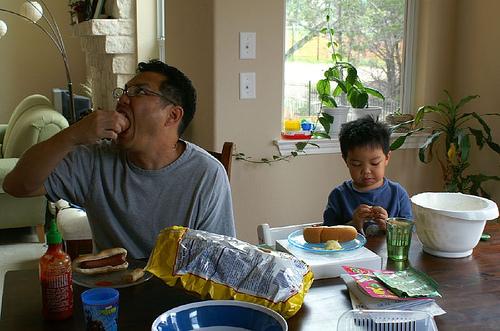Is the child sleeping?
Keep it brief. No. How many people are there?
Concise answer only. 2. How many people are in this picture?
Quick response, please. 2. Does the man appear hungry?
Keep it brief. Yes. 